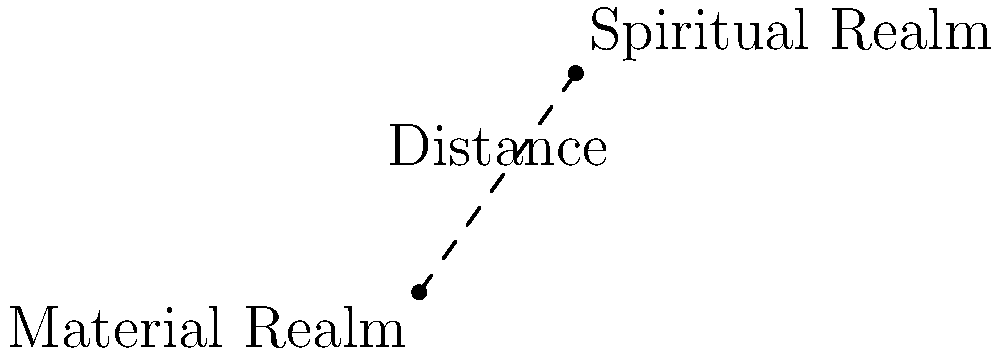In a mystical coordinate system, the Material Realm is represented by the point (0,0) and the Spiritual Realm by the point (5,7). Calculate the metaphysical distance between these two realms, symbolizing the soul's journey from the material to the spiritual. Round your answer to two decimal places. To calculate the distance between two points in a coordinate system, we can use the distance formula, which is derived from the Pythagorean theorem:

1) The distance formula is: $$d = \sqrt{(x_2 - x_1)^2 + (y_2 - y_1)^2}$$

2) In this case:
   $(x_1, y_1) = (0, 0)$ (Material Realm)
   $(x_2, y_2) = (5, 7)$ (Spiritual Realm)

3) Let's substitute these values into the formula:
   $$d = \sqrt{(5 - 0)^2 + (7 - 0)^2}$$

4) Simplify:
   $$d = \sqrt{5^2 + 7^2}$$

5) Calculate the squares:
   $$d = \sqrt{25 + 49}$$

6) Add under the square root:
   $$d = \sqrt{74}$$

7) Calculate the square root:
   $$d \approx 8.602325267$$

8) Rounding to two decimal places:
   $$d \approx 8.60$$

This distance represents the metaphysical journey of the soul from the material to the spiritual realm.
Answer: 8.60 units 